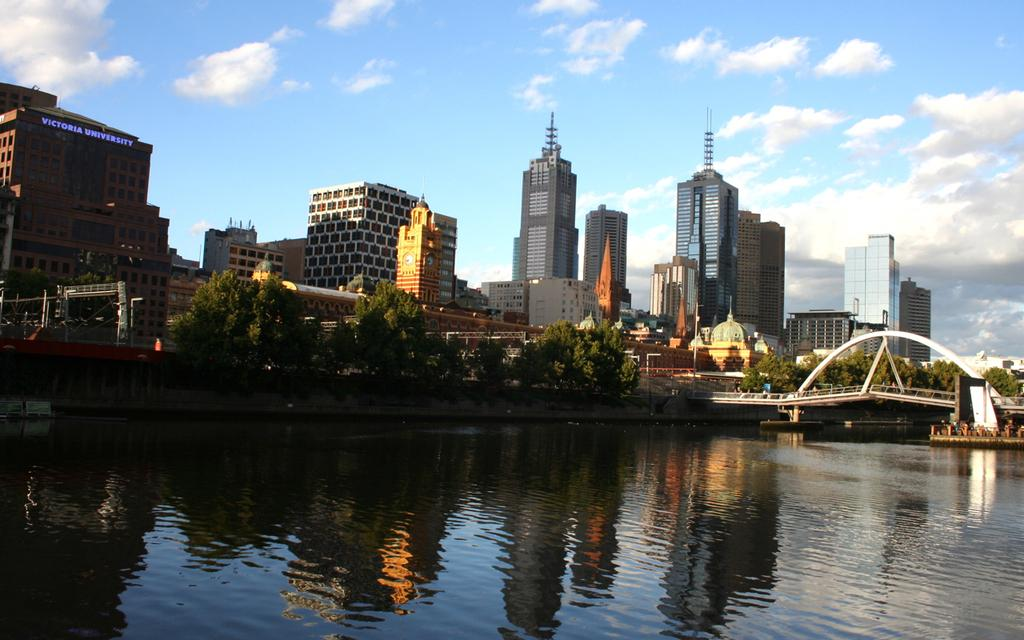What type of structures can be seen in the image? There are buildings in the image. What natural elements are present in the image? There are trees in the image. What man-made feature connects two areas in the image? There is a bridge in the image. What natural feature is visible in the image? There is water visible in the image. What other objects can be seen in the image besides buildings, trees, and a bridge? There are other objects in the image. What can be seen in the background of the image? The sky is visible in the background of the image. How many lamps are hanging from the trees in the image? There are no lamps present in the image; it features buildings, trees, a bridge, water, and other objects. What type of giants can be seen walking across the bridge in the image? There are no giants present in the image; it features buildings, trees, a bridge, water, and other objects. 